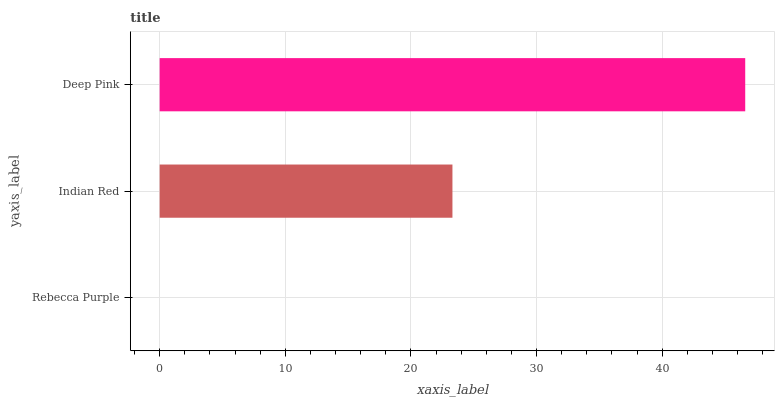Is Rebecca Purple the minimum?
Answer yes or no. Yes. Is Deep Pink the maximum?
Answer yes or no. Yes. Is Indian Red the minimum?
Answer yes or no. No. Is Indian Red the maximum?
Answer yes or no. No. Is Indian Red greater than Rebecca Purple?
Answer yes or no. Yes. Is Rebecca Purple less than Indian Red?
Answer yes or no. Yes. Is Rebecca Purple greater than Indian Red?
Answer yes or no. No. Is Indian Red less than Rebecca Purple?
Answer yes or no. No. Is Indian Red the high median?
Answer yes or no. Yes. Is Indian Red the low median?
Answer yes or no. Yes. Is Deep Pink the high median?
Answer yes or no. No. Is Deep Pink the low median?
Answer yes or no. No. 